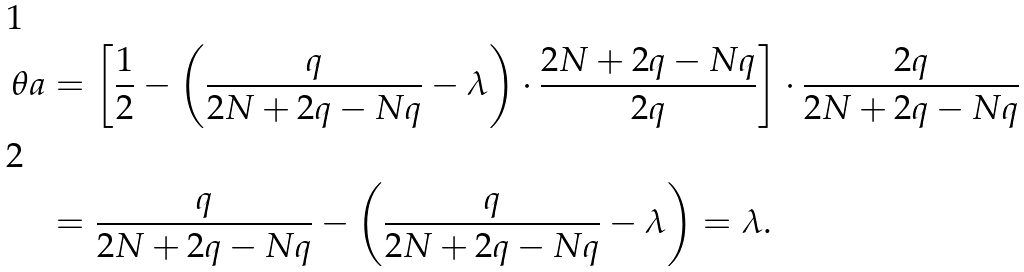Convert formula to latex. <formula><loc_0><loc_0><loc_500><loc_500>\theta a & = \left [ \frac { 1 } { 2 } - \left ( \frac { q } { 2 N + 2 q - N q } - \lambda \right ) \cdot \frac { 2 N + 2 q - N q } { 2 q } \right ] \cdot \frac { 2 q } { 2 N + 2 q - N q } \\ & = \frac { q } { 2 N + 2 q - N q } - \left ( \frac { q } { 2 N + 2 q - N q } - \lambda \right ) = \lambda .</formula> 